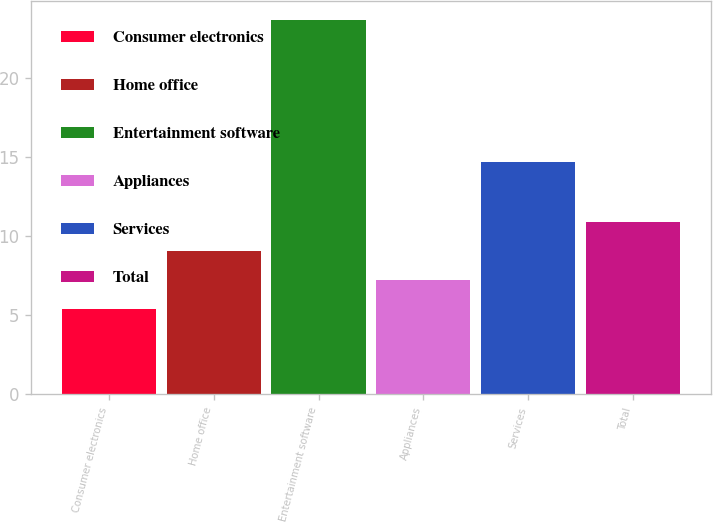Convert chart to OTSL. <chart><loc_0><loc_0><loc_500><loc_500><bar_chart><fcel>Consumer electronics<fcel>Home office<fcel>Entertainment software<fcel>Appliances<fcel>Services<fcel>Total<nl><fcel>5.4<fcel>9.06<fcel>23.7<fcel>7.23<fcel>14.7<fcel>10.89<nl></chart> 